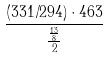Convert formula to latex. <formula><loc_0><loc_0><loc_500><loc_500>\frac { ( 3 3 1 / 2 9 4 ) \cdot 4 6 3 } { \frac { \frac { 1 3 } { 8 } } { 2 } }</formula> 